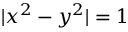Convert formula to latex. <formula><loc_0><loc_0><loc_500><loc_500>| x ^ { 2 } - y ^ { 2 } | = 1</formula> 